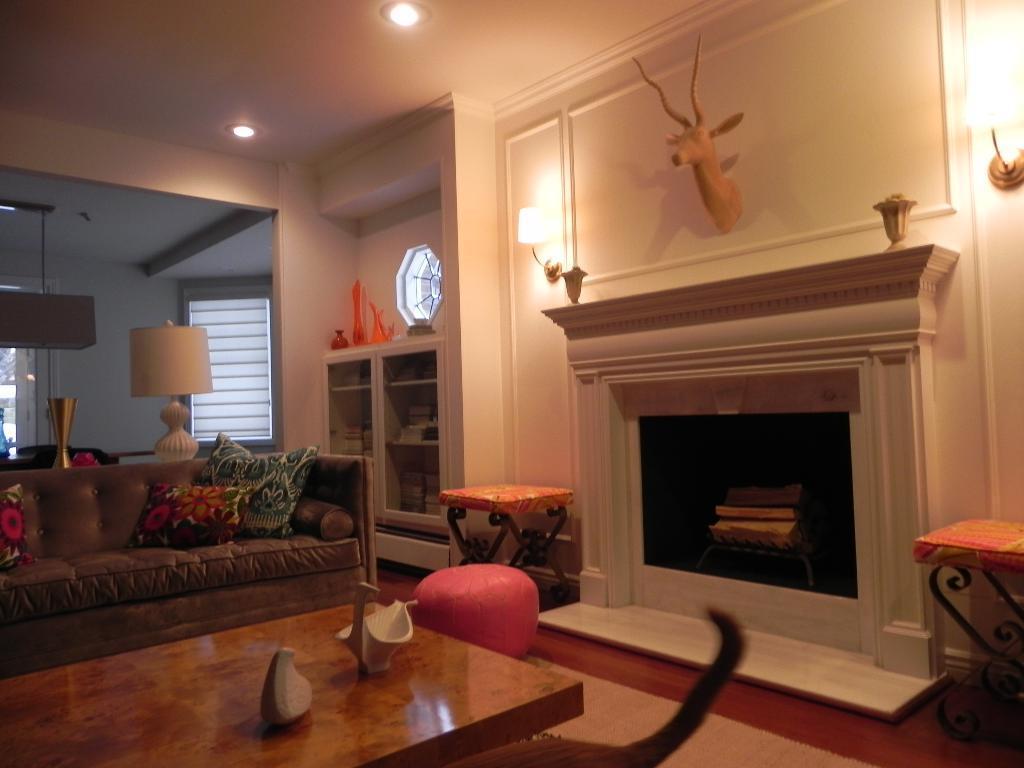How would you summarize this image in a sentence or two? This picture shows an inner view of a house we see a sofa bed and chairs and a fireplace and few lights and a table 